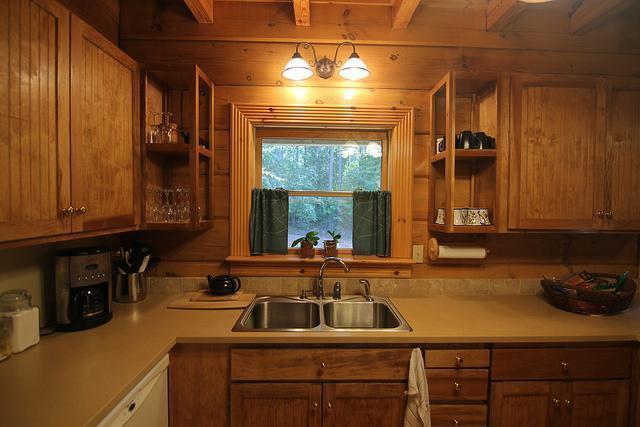How many lights are there in the room?
Give a very brief answer. 2. How many sinks can you see?
Give a very brief answer. 1. 